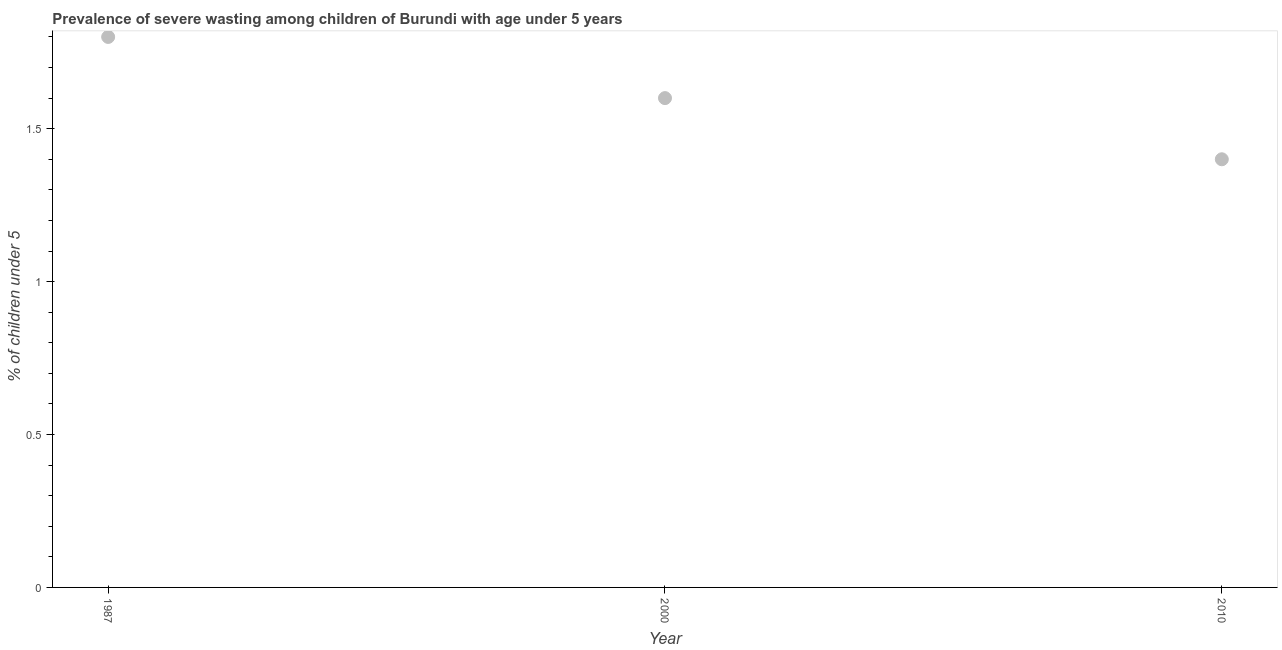What is the prevalence of severe wasting in 2010?
Offer a very short reply. 1.4. Across all years, what is the maximum prevalence of severe wasting?
Your answer should be compact. 1.8. Across all years, what is the minimum prevalence of severe wasting?
Give a very brief answer. 1.4. In which year was the prevalence of severe wasting maximum?
Ensure brevity in your answer.  1987. In which year was the prevalence of severe wasting minimum?
Provide a short and direct response. 2010. What is the sum of the prevalence of severe wasting?
Your answer should be very brief. 4.8. What is the difference between the prevalence of severe wasting in 1987 and 2000?
Your answer should be very brief. 0.2. What is the average prevalence of severe wasting per year?
Give a very brief answer. 1.6. What is the median prevalence of severe wasting?
Your answer should be compact. 1.6. In how many years, is the prevalence of severe wasting greater than 1.1 %?
Ensure brevity in your answer.  3. Do a majority of the years between 1987 and 2000 (inclusive) have prevalence of severe wasting greater than 0.7 %?
Provide a succinct answer. Yes. What is the ratio of the prevalence of severe wasting in 2000 to that in 2010?
Offer a very short reply. 1.14. What is the difference between the highest and the second highest prevalence of severe wasting?
Ensure brevity in your answer.  0.2. What is the difference between the highest and the lowest prevalence of severe wasting?
Your answer should be compact. 0.4. In how many years, is the prevalence of severe wasting greater than the average prevalence of severe wasting taken over all years?
Your answer should be very brief. 2. Does the prevalence of severe wasting monotonically increase over the years?
Provide a short and direct response. No. How many years are there in the graph?
Keep it short and to the point. 3. Does the graph contain any zero values?
Your answer should be very brief. No. What is the title of the graph?
Keep it short and to the point. Prevalence of severe wasting among children of Burundi with age under 5 years. What is the label or title of the Y-axis?
Give a very brief answer.  % of children under 5. What is the  % of children under 5 in 1987?
Offer a very short reply. 1.8. What is the  % of children under 5 in 2000?
Your answer should be compact. 1.6. What is the  % of children under 5 in 2010?
Make the answer very short. 1.4. What is the difference between the  % of children under 5 in 1987 and 2000?
Keep it short and to the point. 0.2. What is the difference between the  % of children under 5 in 2000 and 2010?
Provide a succinct answer. 0.2. What is the ratio of the  % of children under 5 in 1987 to that in 2010?
Give a very brief answer. 1.29. What is the ratio of the  % of children under 5 in 2000 to that in 2010?
Provide a succinct answer. 1.14. 